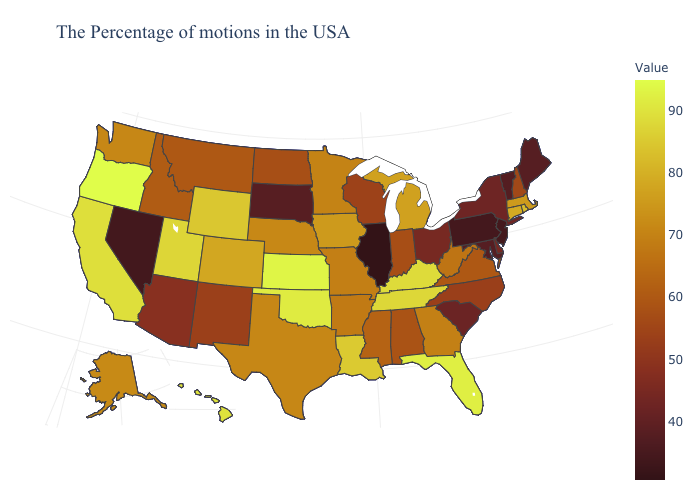Among the states that border Idaho , which have the highest value?
Write a very short answer. Oregon. Which states have the lowest value in the USA?
Keep it brief. Illinois. Among the states that border New York , does Massachusetts have the highest value?
Answer briefly. No. Does Oregon have the highest value in the USA?
Answer briefly. Yes. Which states hav the highest value in the MidWest?
Write a very short answer. Kansas. 